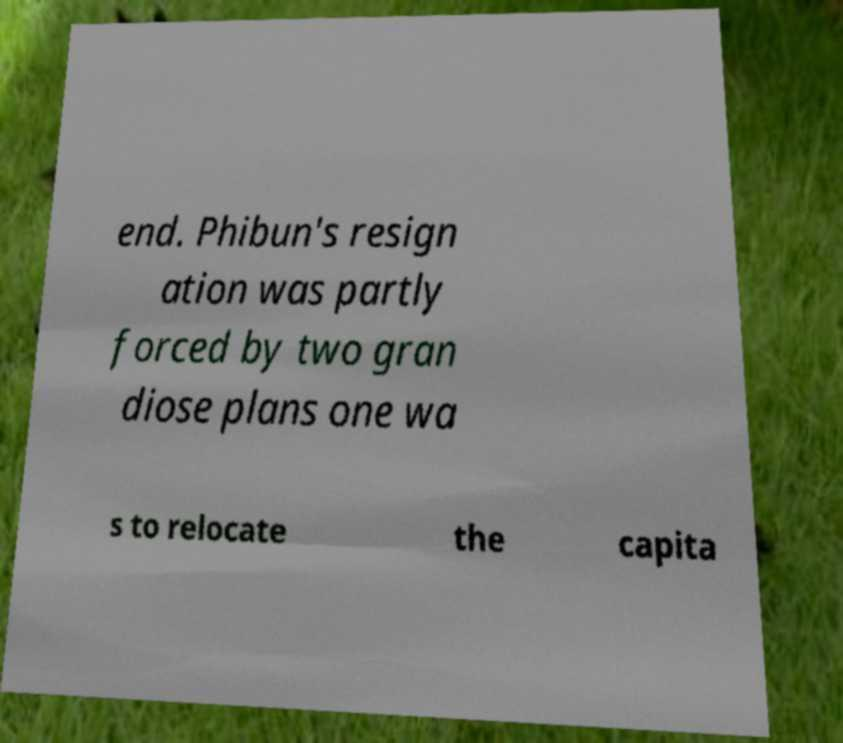Can you read and provide the text displayed in the image?This photo seems to have some interesting text. Can you extract and type it out for me? end. Phibun's resign ation was partly forced by two gran diose plans one wa s to relocate the capita 